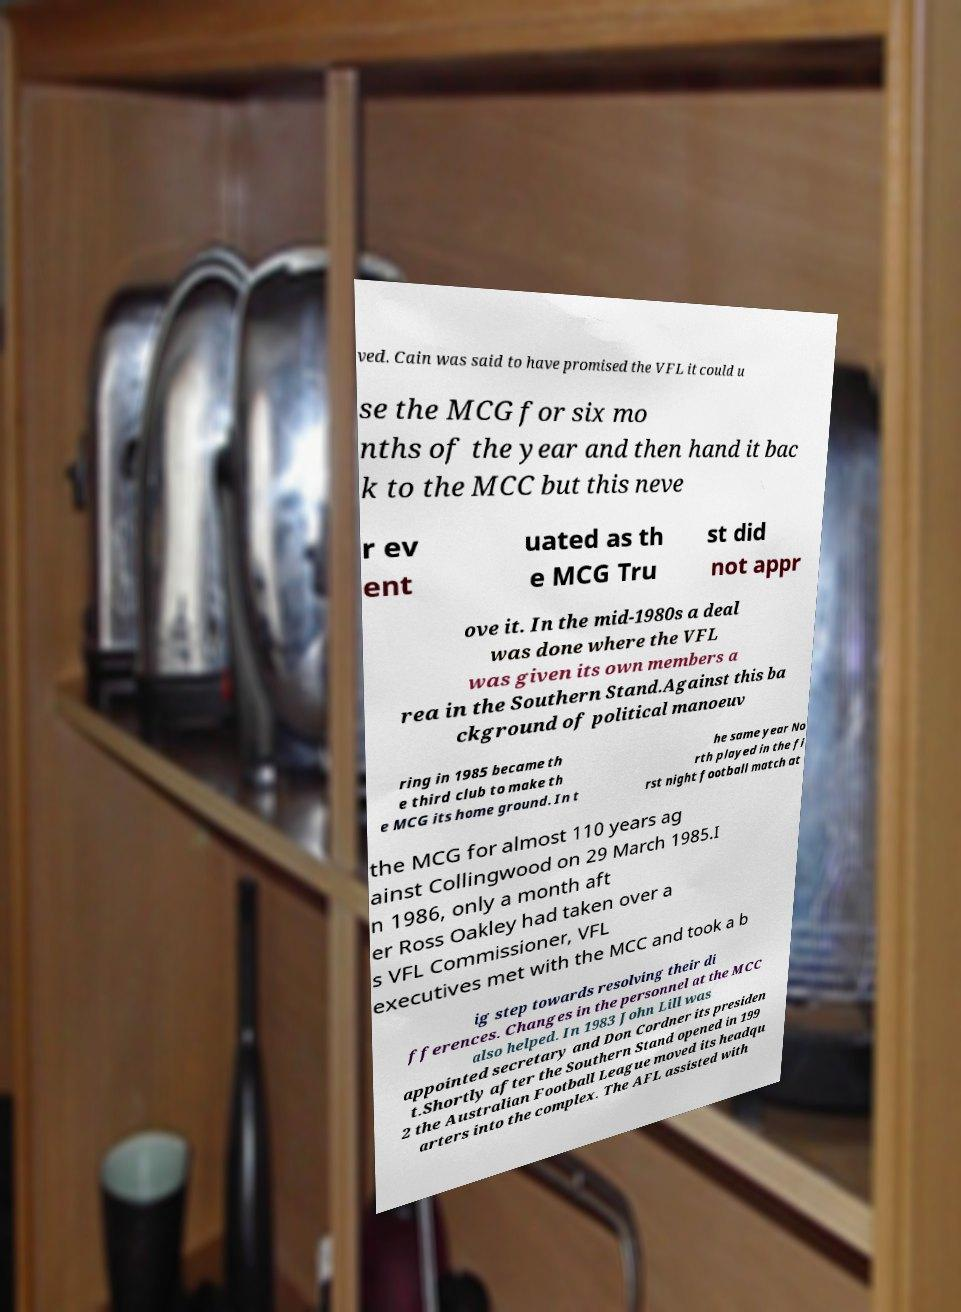Could you assist in decoding the text presented in this image and type it out clearly? ved. Cain was said to have promised the VFL it could u se the MCG for six mo nths of the year and then hand it bac k to the MCC but this neve r ev ent uated as th e MCG Tru st did not appr ove it. In the mid-1980s a deal was done where the VFL was given its own members a rea in the Southern Stand.Against this ba ckground of political manoeuv ring in 1985 became th e third club to make th e MCG its home ground. In t he same year No rth played in the fi rst night football match at the MCG for almost 110 years ag ainst Collingwood on 29 March 1985.I n 1986, only a month aft er Ross Oakley had taken over a s VFL Commissioner, VFL executives met with the MCC and took a b ig step towards resolving their di fferences. Changes in the personnel at the MCC also helped. In 1983 John Lill was appointed secretary and Don Cordner its presiden t.Shortly after the Southern Stand opened in 199 2 the Australian Football League moved its headqu arters into the complex. The AFL assisted with 